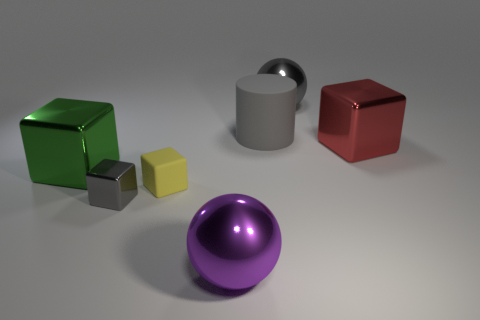Subtract all yellow cubes. Subtract all purple balls. How many cubes are left? 3 Add 2 purple things. How many objects exist? 9 Subtract all spheres. How many objects are left? 5 Subtract all gray shiny objects. Subtract all large gray matte cylinders. How many objects are left? 4 Add 5 green metal objects. How many green metal objects are left? 6 Add 7 small gray things. How many small gray things exist? 8 Subtract 0 cyan cubes. How many objects are left? 7 